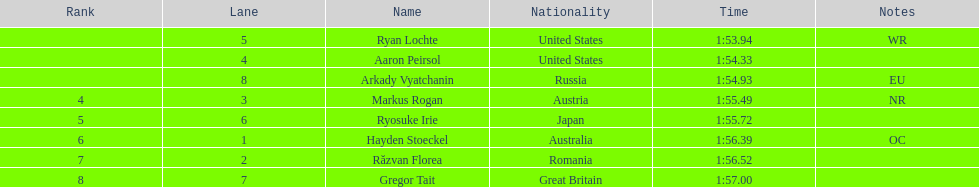Give me the full table as a dictionary. {'header': ['Rank', 'Lane', 'Name', 'Nationality', 'Time', 'Notes'], 'rows': [['', '5', 'Ryan Lochte', 'United States', '1:53.94', 'WR'], ['', '4', 'Aaron Peirsol', 'United States', '1:54.33', ''], ['', '8', 'Arkady Vyatchanin', 'Russia', '1:54.93', 'EU'], ['4', '3', 'Markus Rogan', 'Austria', '1:55.49', 'NR'], ['5', '6', 'Ryosuke Irie', 'Japan', '1:55.72', ''], ['6', '1', 'Hayden Stoeckel', 'Australia', '1:56.39', 'OC'], ['7', '2', 'Răzvan Florea', 'Romania', '1:56.52', ''], ['8', '7', 'Gregor Tait', 'Great Britain', '1:57.00', '']]} Which country had the most medals in the competition? United States. 